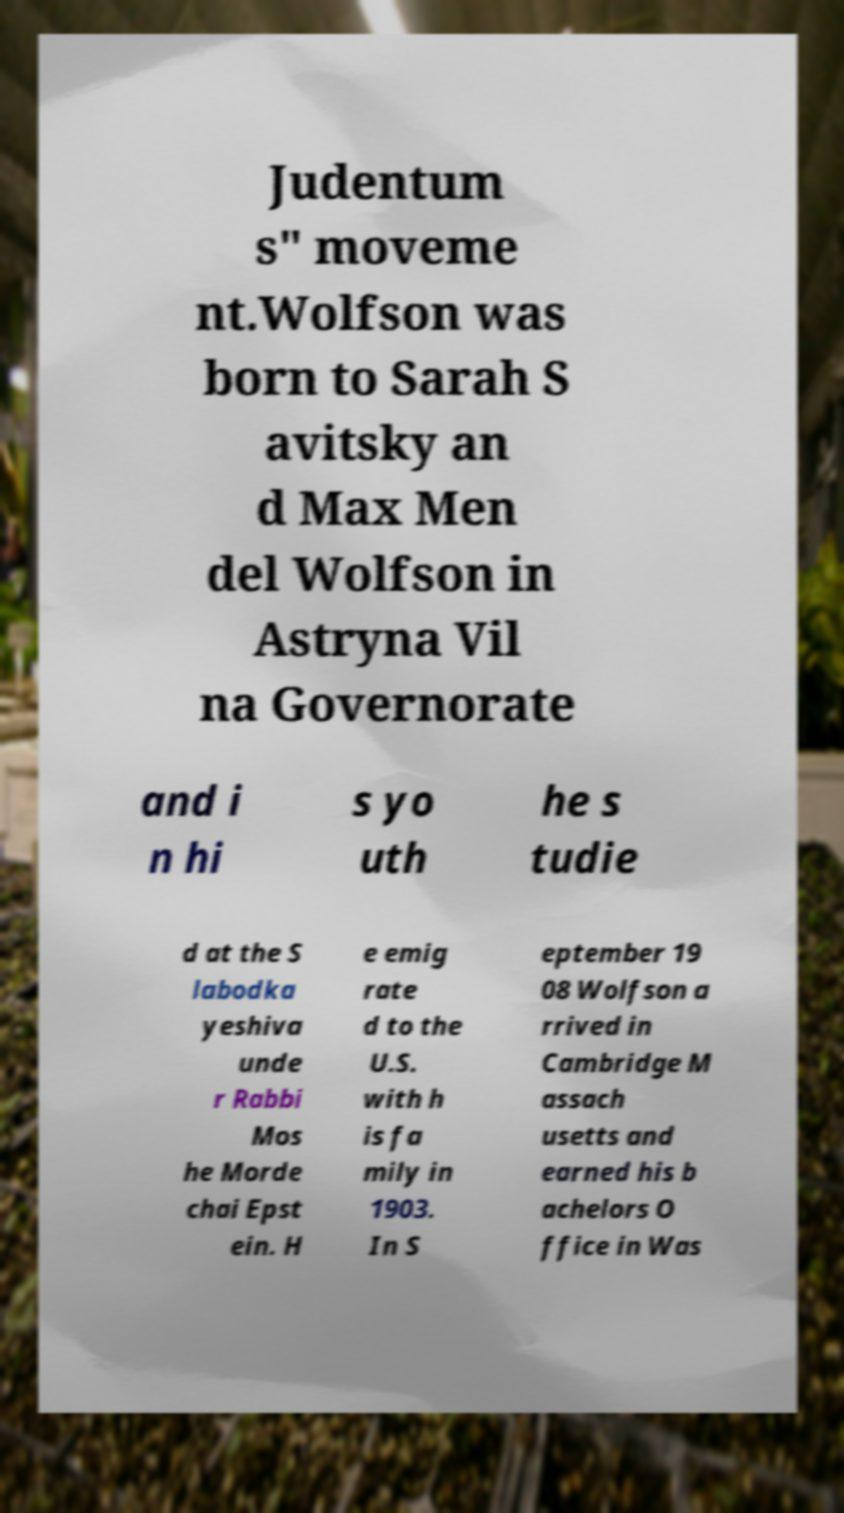Could you extract and type out the text from this image? Judentum s" moveme nt.Wolfson was born to Sarah S avitsky an d Max Men del Wolfson in Astryna Vil na Governorate and i n hi s yo uth he s tudie d at the S labodka yeshiva unde r Rabbi Mos he Morde chai Epst ein. H e emig rate d to the U.S. with h is fa mily in 1903. In S eptember 19 08 Wolfson a rrived in Cambridge M assach usetts and earned his b achelors O ffice in Was 